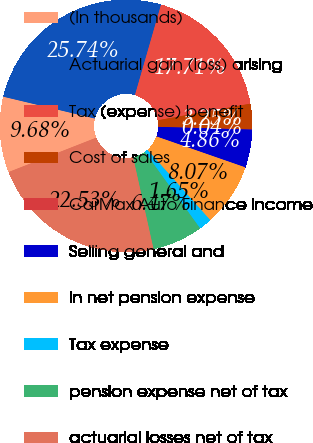Convert chart to OTSL. <chart><loc_0><loc_0><loc_500><loc_500><pie_chart><fcel>(In thousands)<fcel>Actuarial gain (loss) arising<fcel>Tax (expense) benefit<fcel>Cost of sales<fcel>CarMax Auto Finance income<fcel>Selling general and<fcel>in net pension expense<fcel>Tax expense<fcel>pension expense net of tax<fcel>actuarial losses net of tax<nl><fcel>9.68%<fcel>25.74%<fcel>17.71%<fcel>3.25%<fcel>0.04%<fcel>4.86%<fcel>8.07%<fcel>1.65%<fcel>6.47%<fcel>22.53%<nl></chart> 